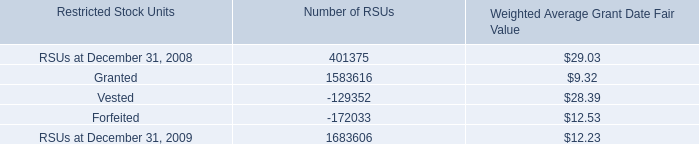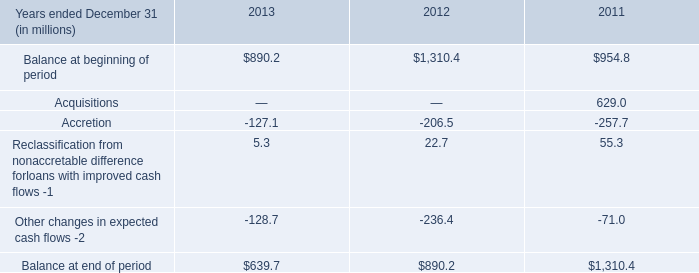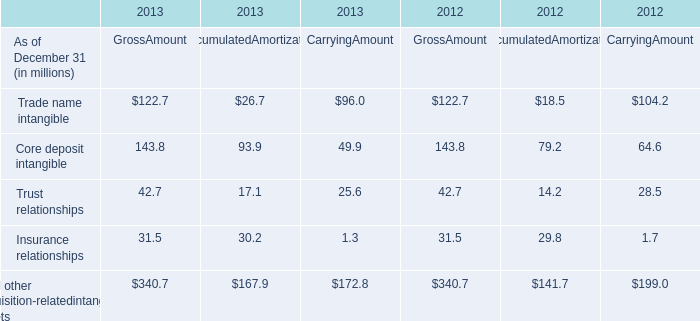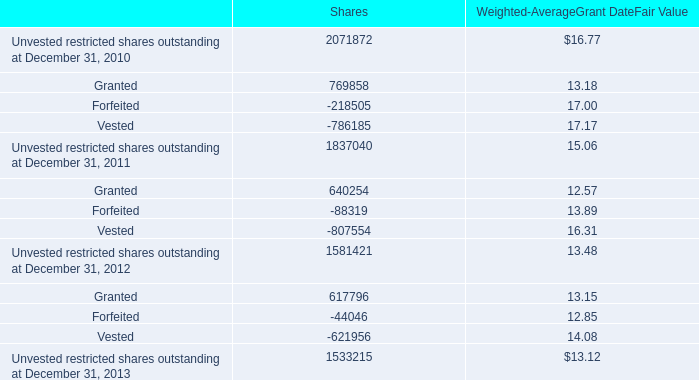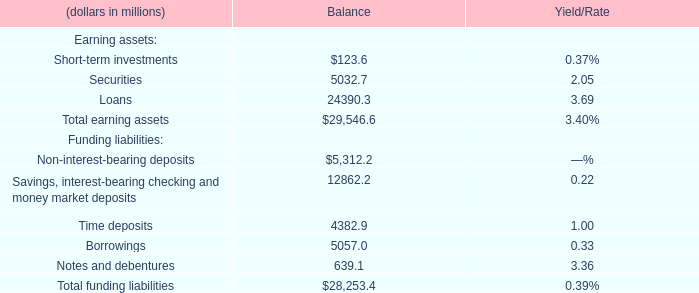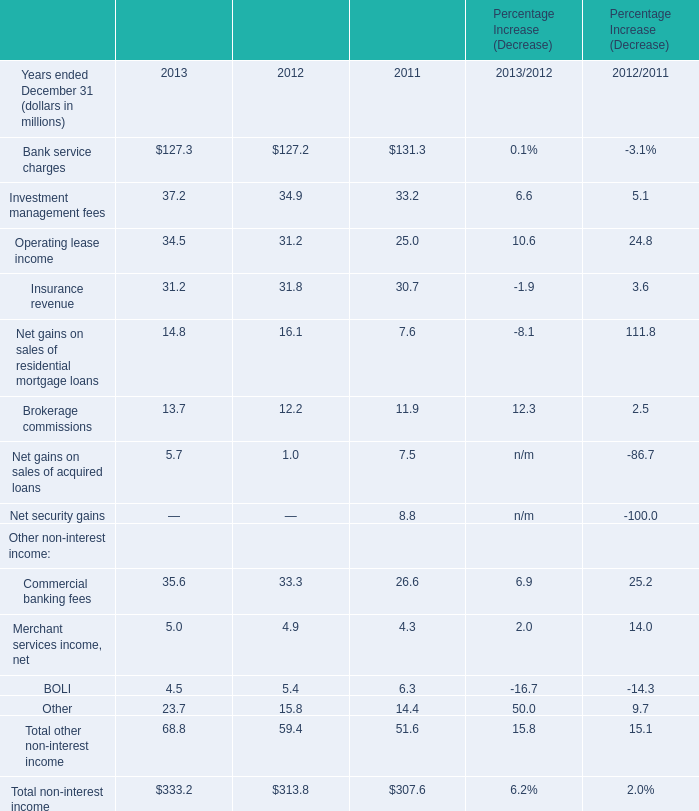What's the 30 % of Total funding liabilities for Balance? (in million) 
Computations: (28253.4 * 0.3)
Answer: 8476.02. 